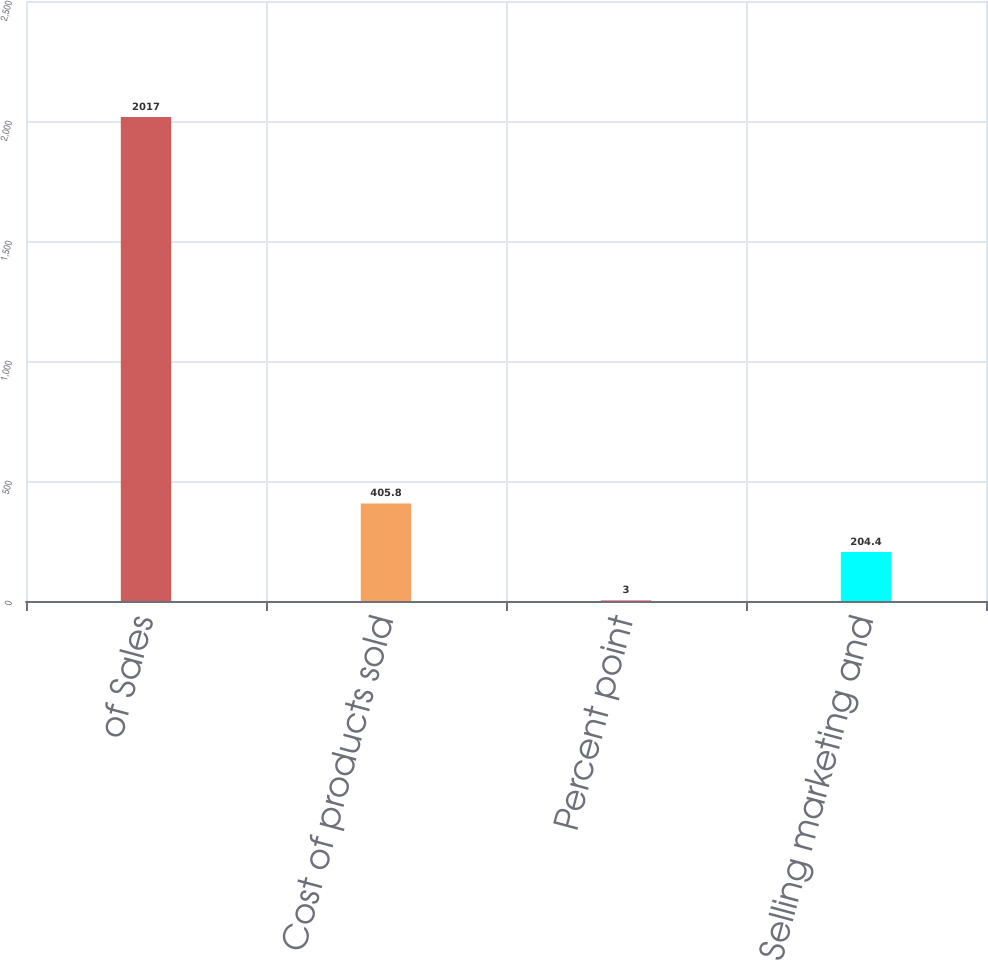Convert chart to OTSL. <chart><loc_0><loc_0><loc_500><loc_500><bar_chart><fcel>of Sales<fcel>Cost of products sold<fcel>Percent point<fcel>Selling marketing and<nl><fcel>2017<fcel>405.8<fcel>3<fcel>204.4<nl></chart> 